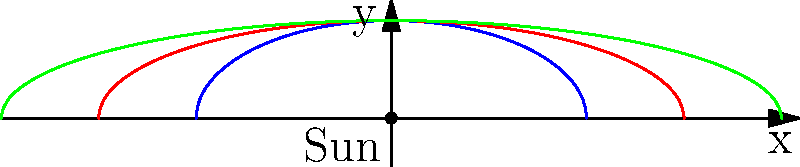In the diagram above, three elliptical orbits around the Sun are shown. Which orbit has the highest eccentricity? How does this relate to the concept of "pressing" in the Phoenix Wright series? Let's approach this step-by-step:

1. Eccentricity in elliptical orbits:
   The eccentricity of an ellipse is a measure of how much it deviates from a perfect circle. It's defined by the equation:

   $$ e = \sqrt{1 - \frac{b^2}{a^2}} $$

   where $a$ is the semi-major axis and $b$ is the semi-minor axis.

2. Analyzing the orbits:
   - Blue orbit: smallest and most circular
   - Red orbit: medium-sized and slightly more elliptical
   - Green orbit: largest and most elliptical

3. Comparing to perfect circles:
   The more an orbit deviates from a perfect circle, the higher its eccentricity.

4. Conclusion:
   The green orbit has the highest eccentricity as it's the most elongated.

5. Relation to "pressing" in Phoenix Wright:
   In the Ace Attorney series, "pressing" is a technique used to extract more information from witnesses. Similarly, in astronomy, we "press" for more details about celestial bodies by analyzing their orbital patterns. The more eccentric the orbit, the more we can learn about the forces acting on the body, just as pressing a witness can reveal more about a case.

This comparison demonstrates how techniques in different fields (law and astronomy) can be used to uncover hidden information, bridging the gap between seemingly unrelated genres.
Answer: Green orbit; both involve extracting hidden information 